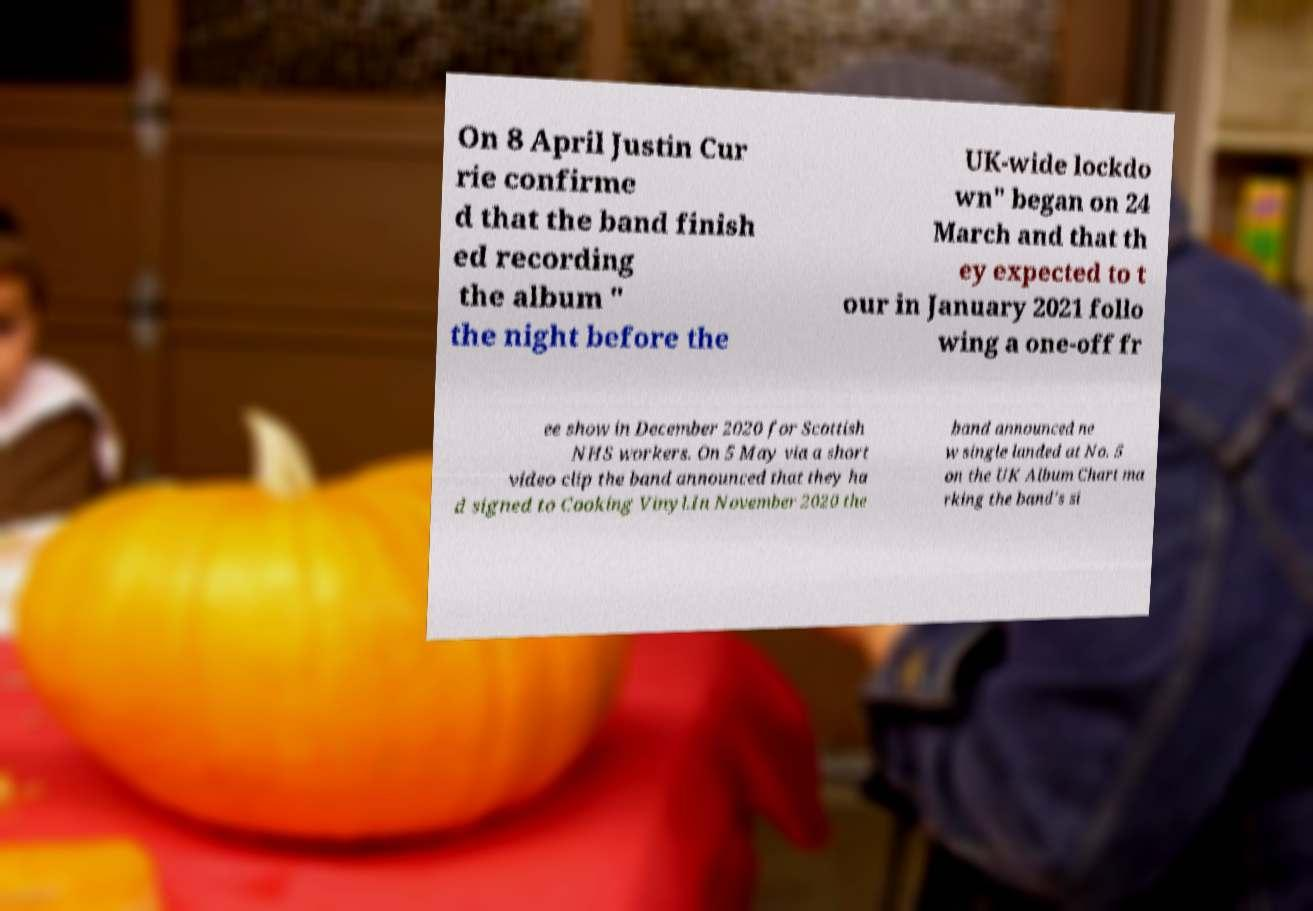I need the written content from this picture converted into text. Can you do that? On 8 April Justin Cur rie confirme d that the band finish ed recording the album " the night before the UK-wide lockdo wn" began on 24 March and that th ey expected to t our in January 2021 follo wing a one-off fr ee show in December 2020 for Scottish NHS workers. On 5 May via a short video clip the band announced that they ha d signed to Cooking Vinyl.In November 2020 the band announced ne w single landed at No. 5 on the UK Album Chart ma rking the band's si 